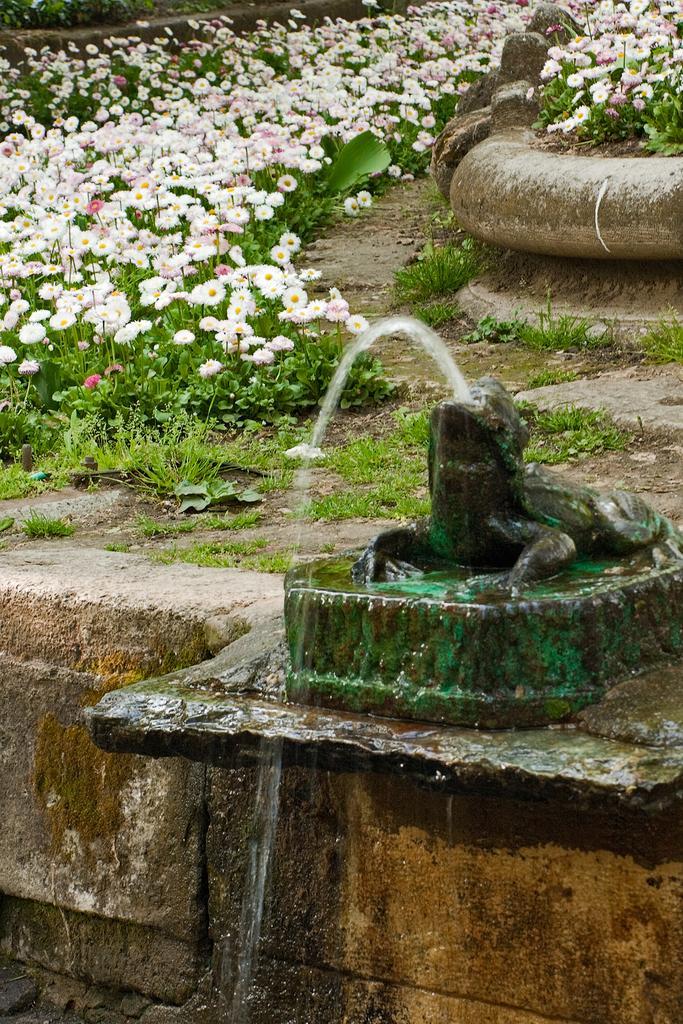How would you summarize this image in a sentence or two? This image is taken outdoors. At the bottom of the image there is a wall. On the right side of the image there is a fountain and there is a sculpture. In the background there are many plants with flowers, green leaves and stems. Those flowers are pink and white in colors. 